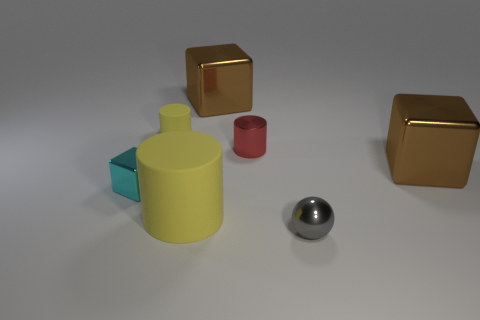There is a big shiny thing left of the metal sphere; what number of small blocks are to the left of it?
Keep it short and to the point. 1. There is a cylinder that is the same color as the tiny matte object; what is its material?
Give a very brief answer. Rubber. What number of other things are the same color as the metallic sphere?
Your response must be concise. 0. There is a tiny cylinder that is on the right side of the tiny cylinder to the left of the big matte cylinder; what is its color?
Ensure brevity in your answer.  Red. Are there any big matte things of the same color as the tiny block?
Your response must be concise. No. What number of shiny objects are red objects or small cyan objects?
Your response must be concise. 2. Is there another cyan block that has the same material as the cyan block?
Give a very brief answer. No. What number of metal things are right of the red cylinder and behind the shiny ball?
Make the answer very short. 1. Are there fewer matte cylinders that are in front of the large matte cylinder than large yellow matte things behind the tiny red object?
Your answer should be compact. No. Is the shape of the cyan object the same as the big yellow object?
Offer a terse response. No. 